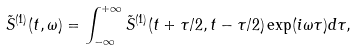<formula> <loc_0><loc_0><loc_500><loc_500>\tilde { S } ^ { ( 1 ) } ( t , \omega ) = \int _ { - \infty } ^ { + \infty } \tilde { S } ^ { ( 1 ) } ( t + \tau / 2 , t - \tau / 2 ) \exp ( i \omega \tau ) d \tau ,</formula> 